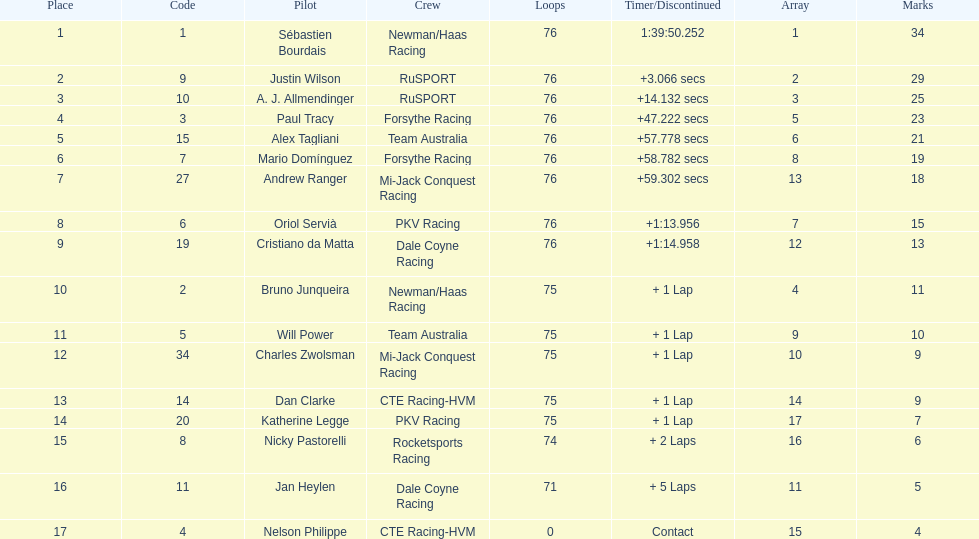Which driver has the least amount of points? Nelson Philippe. 